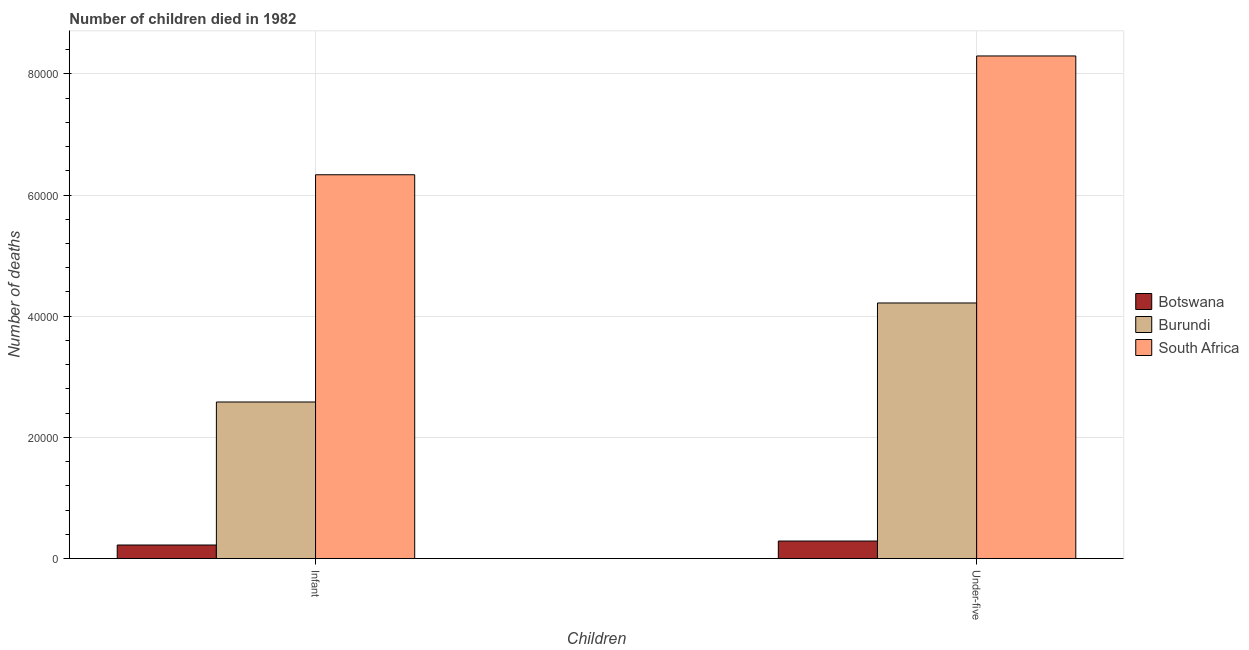How many different coloured bars are there?
Keep it short and to the point. 3. How many groups of bars are there?
Offer a terse response. 2. Are the number of bars per tick equal to the number of legend labels?
Give a very brief answer. Yes. What is the label of the 2nd group of bars from the left?
Your response must be concise. Under-five. What is the number of under-five deaths in Botswana?
Make the answer very short. 2893. Across all countries, what is the maximum number of infant deaths?
Ensure brevity in your answer.  6.34e+04. Across all countries, what is the minimum number of infant deaths?
Provide a short and direct response. 2239. In which country was the number of under-five deaths maximum?
Make the answer very short. South Africa. In which country was the number of infant deaths minimum?
Keep it short and to the point. Botswana. What is the total number of infant deaths in the graph?
Make the answer very short. 9.14e+04. What is the difference between the number of infant deaths in Botswana and that in Burundi?
Your response must be concise. -2.36e+04. What is the difference between the number of infant deaths in Burundi and the number of under-five deaths in South Africa?
Make the answer very short. -5.71e+04. What is the average number of under-five deaths per country?
Offer a terse response. 4.27e+04. What is the difference between the number of under-five deaths and number of infant deaths in Botswana?
Offer a very short reply. 654. In how many countries, is the number of under-five deaths greater than 24000 ?
Your response must be concise. 2. What is the ratio of the number of infant deaths in South Africa to that in Botswana?
Your response must be concise. 28.29. What does the 3rd bar from the left in Infant represents?
Give a very brief answer. South Africa. What does the 2nd bar from the right in Under-five represents?
Provide a succinct answer. Burundi. How many bars are there?
Keep it short and to the point. 6. How many countries are there in the graph?
Give a very brief answer. 3. Are the values on the major ticks of Y-axis written in scientific E-notation?
Your response must be concise. No. Does the graph contain grids?
Your response must be concise. Yes. Where does the legend appear in the graph?
Your answer should be very brief. Center right. How are the legend labels stacked?
Provide a succinct answer. Vertical. What is the title of the graph?
Offer a terse response. Number of children died in 1982. What is the label or title of the X-axis?
Make the answer very short. Children. What is the label or title of the Y-axis?
Provide a succinct answer. Number of deaths. What is the Number of deaths in Botswana in Infant?
Your answer should be compact. 2239. What is the Number of deaths in Burundi in Infant?
Keep it short and to the point. 2.58e+04. What is the Number of deaths of South Africa in Infant?
Provide a succinct answer. 6.34e+04. What is the Number of deaths in Botswana in Under-five?
Your answer should be compact. 2893. What is the Number of deaths of Burundi in Under-five?
Provide a short and direct response. 4.22e+04. What is the Number of deaths in South Africa in Under-five?
Make the answer very short. 8.30e+04. Across all Children, what is the maximum Number of deaths in Botswana?
Your answer should be compact. 2893. Across all Children, what is the maximum Number of deaths in Burundi?
Give a very brief answer. 4.22e+04. Across all Children, what is the maximum Number of deaths in South Africa?
Ensure brevity in your answer.  8.30e+04. Across all Children, what is the minimum Number of deaths in Botswana?
Offer a very short reply. 2239. Across all Children, what is the minimum Number of deaths in Burundi?
Make the answer very short. 2.58e+04. Across all Children, what is the minimum Number of deaths in South Africa?
Keep it short and to the point. 6.34e+04. What is the total Number of deaths of Botswana in the graph?
Give a very brief answer. 5132. What is the total Number of deaths of Burundi in the graph?
Make the answer very short. 6.80e+04. What is the total Number of deaths of South Africa in the graph?
Give a very brief answer. 1.46e+05. What is the difference between the Number of deaths in Botswana in Infant and that in Under-five?
Provide a succinct answer. -654. What is the difference between the Number of deaths in Burundi in Infant and that in Under-five?
Keep it short and to the point. -1.63e+04. What is the difference between the Number of deaths of South Africa in Infant and that in Under-five?
Provide a succinct answer. -1.96e+04. What is the difference between the Number of deaths of Botswana in Infant and the Number of deaths of Burundi in Under-five?
Offer a terse response. -3.99e+04. What is the difference between the Number of deaths of Botswana in Infant and the Number of deaths of South Africa in Under-five?
Offer a very short reply. -8.07e+04. What is the difference between the Number of deaths of Burundi in Infant and the Number of deaths of South Africa in Under-five?
Your answer should be compact. -5.71e+04. What is the average Number of deaths of Botswana per Children?
Ensure brevity in your answer.  2566. What is the average Number of deaths in Burundi per Children?
Keep it short and to the point. 3.40e+04. What is the average Number of deaths in South Africa per Children?
Provide a succinct answer. 7.32e+04. What is the difference between the Number of deaths in Botswana and Number of deaths in Burundi in Infant?
Your response must be concise. -2.36e+04. What is the difference between the Number of deaths of Botswana and Number of deaths of South Africa in Infant?
Provide a short and direct response. -6.11e+04. What is the difference between the Number of deaths of Burundi and Number of deaths of South Africa in Infant?
Provide a succinct answer. -3.75e+04. What is the difference between the Number of deaths of Botswana and Number of deaths of Burundi in Under-five?
Provide a short and direct response. -3.93e+04. What is the difference between the Number of deaths in Botswana and Number of deaths in South Africa in Under-five?
Provide a short and direct response. -8.01e+04. What is the difference between the Number of deaths in Burundi and Number of deaths in South Africa in Under-five?
Give a very brief answer. -4.08e+04. What is the ratio of the Number of deaths of Botswana in Infant to that in Under-five?
Offer a very short reply. 0.77. What is the ratio of the Number of deaths in Burundi in Infant to that in Under-five?
Provide a succinct answer. 0.61. What is the ratio of the Number of deaths of South Africa in Infant to that in Under-five?
Provide a succinct answer. 0.76. What is the difference between the highest and the second highest Number of deaths in Botswana?
Ensure brevity in your answer.  654. What is the difference between the highest and the second highest Number of deaths in Burundi?
Keep it short and to the point. 1.63e+04. What is the difference between the highest and the second highest Number of deaths in South Africa?
Your answer should be very brief. 1.96e+04. What is the difference between the highest and the lowest Number of deaths of Botswana?
Provide a succinct answer. 654. What is the difference between the highest and the lowest Number of deaths of Burundi?
Your answer should be very brief. 1.63e+04. What is the difference between the highest and the lowest Number of deaths in South Africa?
Make the answer very short. 1.96e+04. 